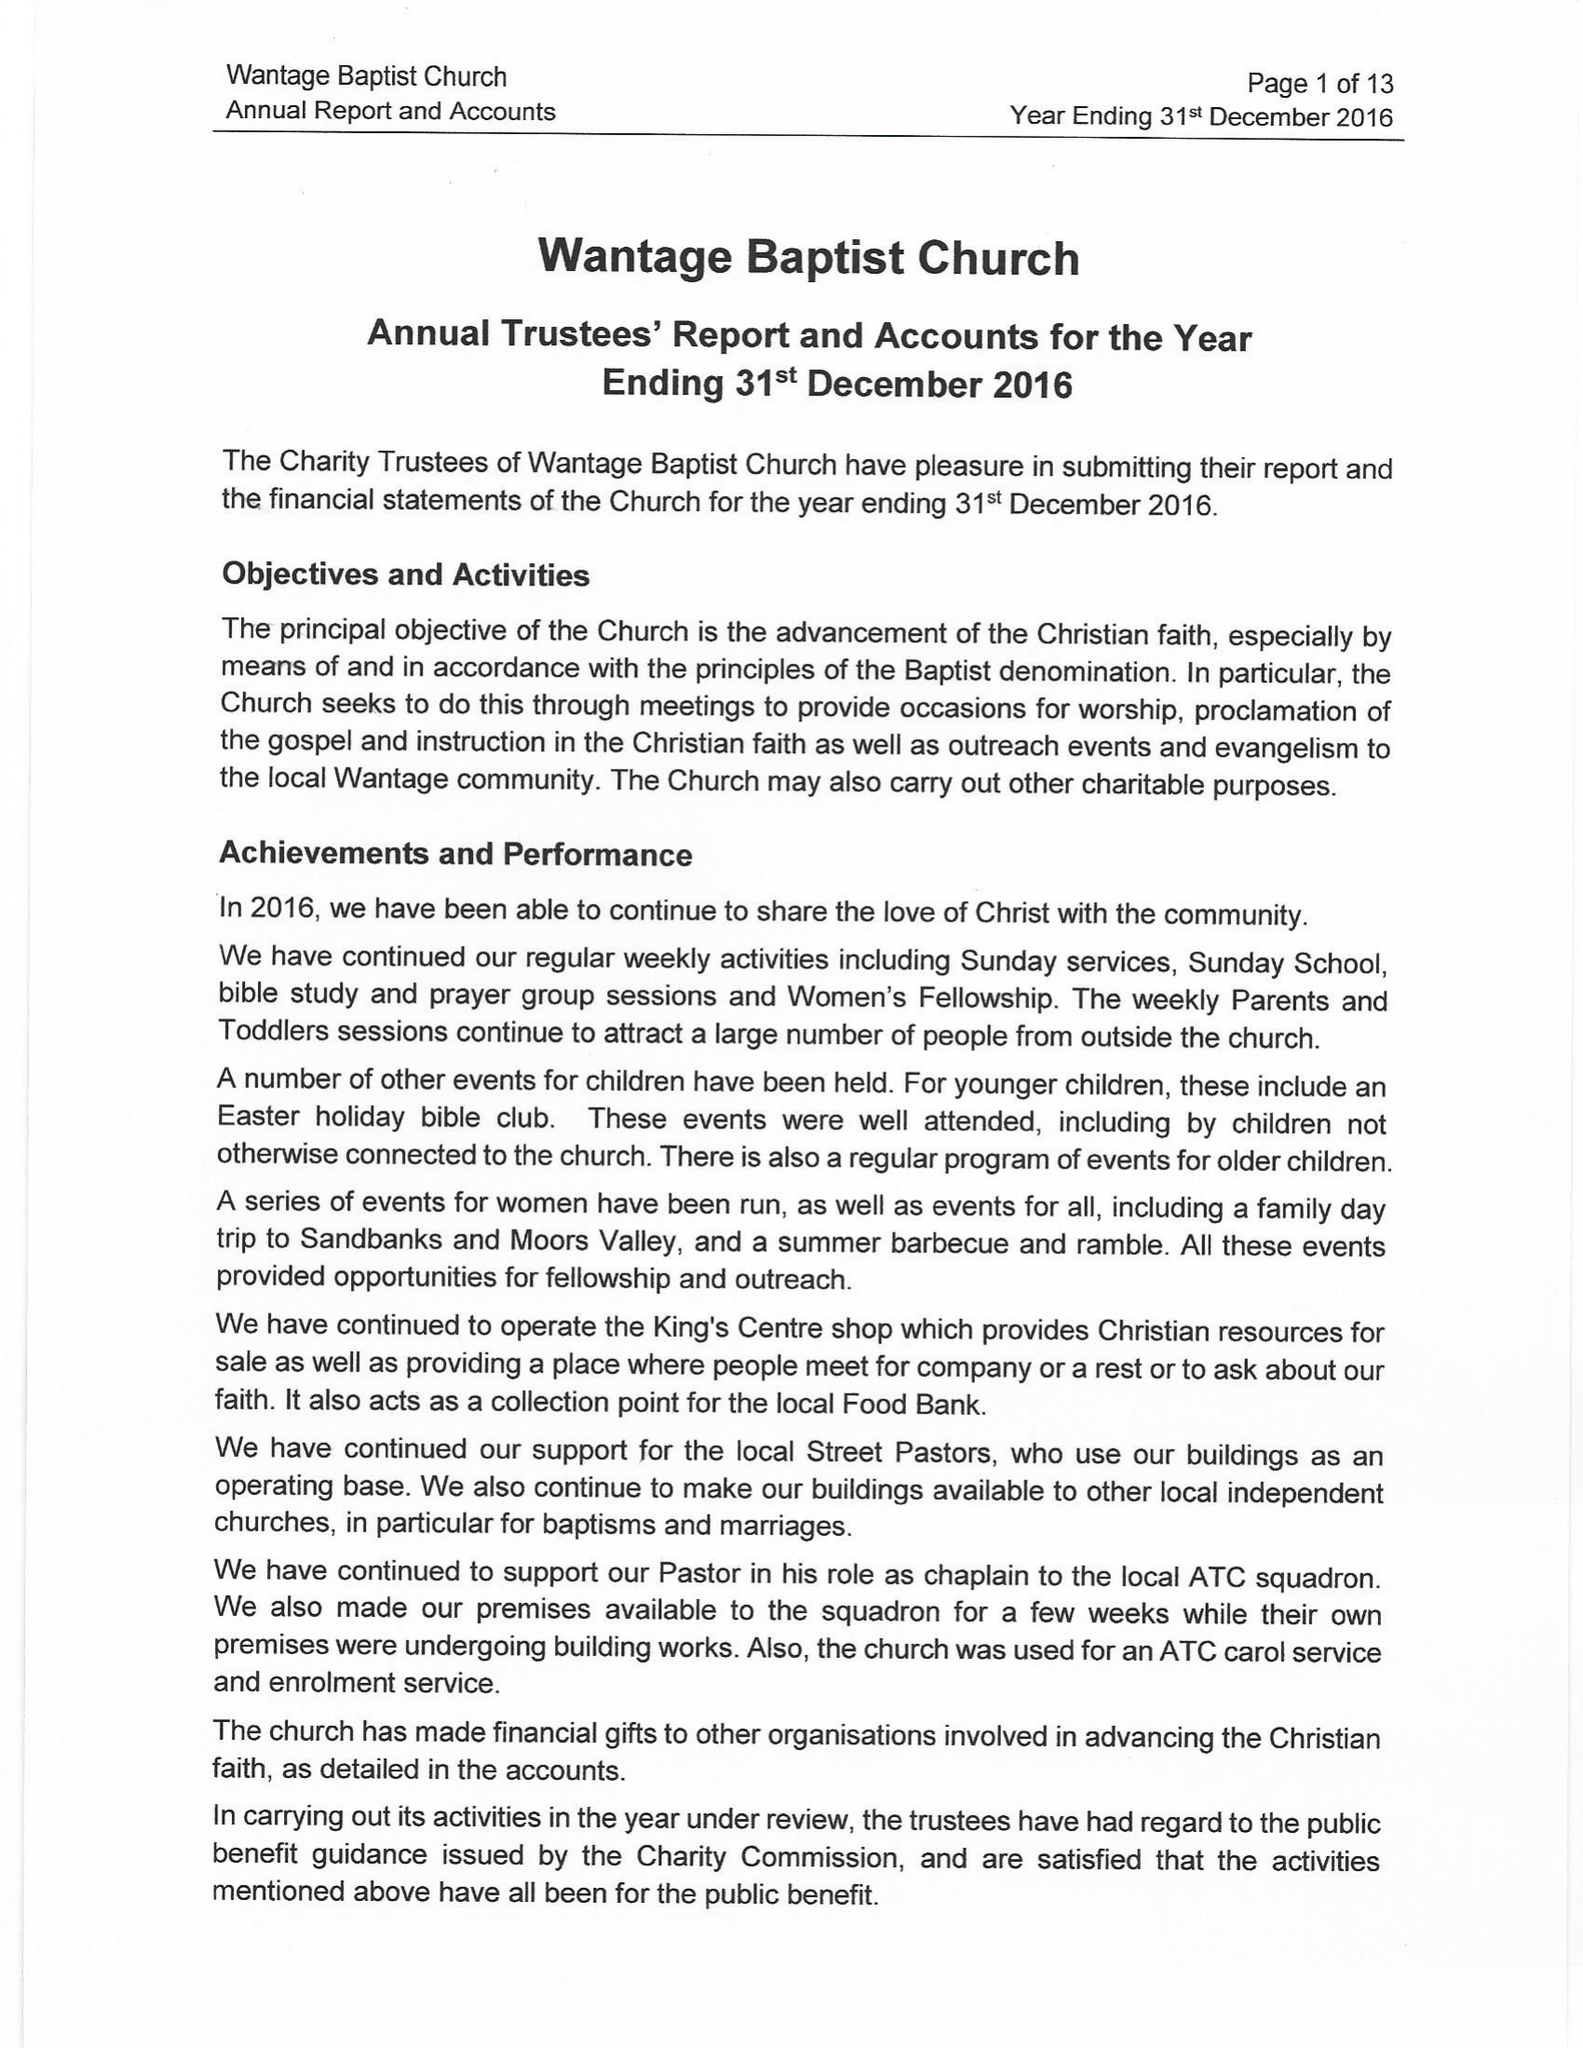What is the value for the address__street_line?
Answer the question using a single word or phrase. 6 MILL STREET 